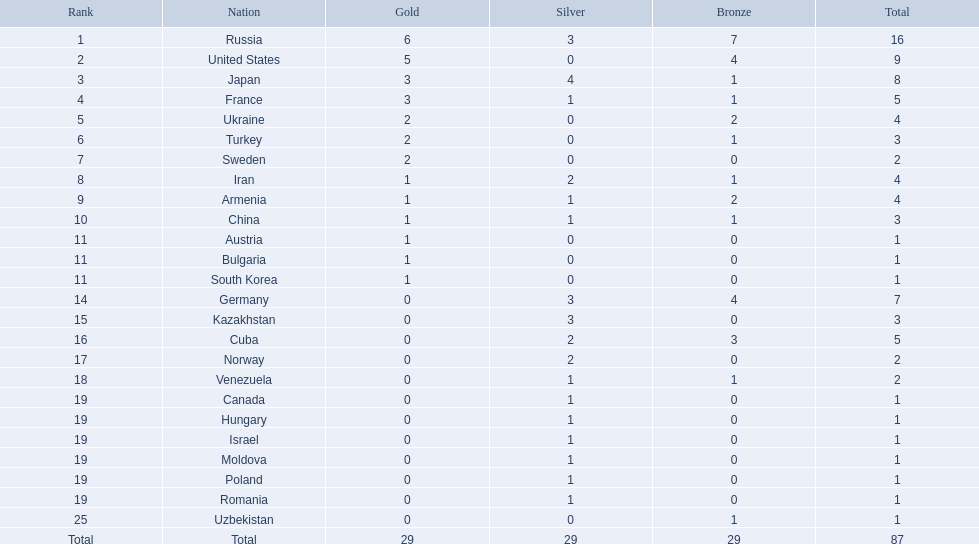Which nations have gold medals? Russia, United States, Japan, France, Ukraine, Turkey, Sweden, Iran, Armenia, China, Austria, Bulgaria, South Korea. Of those nations, which have only one gold medal? Iran, Armenia, China, Austria, Bulgaria, South Korea. Of those nations, which has no bronze or silver medals? Austria. How many gold medals were won by the united states? 5. Who obtained over 5 gold medals? Russia. 